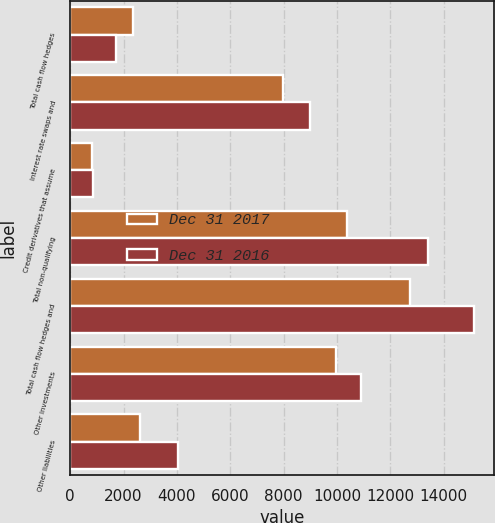<chart> <loc_0><loc_0><loc_500><loc_500><stacked_bar_chart><ecel><fcel>Total cash flow hedges<fcel>Interest rate swaps and<fcel>Credit derivatives that assume<fcel>Total non-qualifying<fcel>Total cash flow hedges and<fcel>Other investments<fcel>Other liabilities<nl><fcel>Dec 31 2017<fcel>2343<fcel>7986<fcel>823<fcel>10387<fcel>12730<fcel>9957<fcel>2620<nl><fcel>Dec 31 2016<fcel>1721<fcel>8969<fcel>851<fcel>13396<fcel>15117<fcel>10888<fcel>4028<nl></chart> 